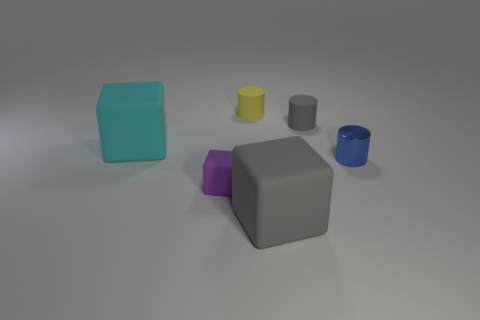Add 3 purple things. How many objects exist? 9 Add 3 matte blocks. How many matte blocks exist? 6 Subtract 0 red spheres. How many objects are left? 6 Subtract all small purple things. Subtract all gray matte cylinders. How many objects are left? 4 Add 2 blue cylinders. How many blue cylinders are left? 3 